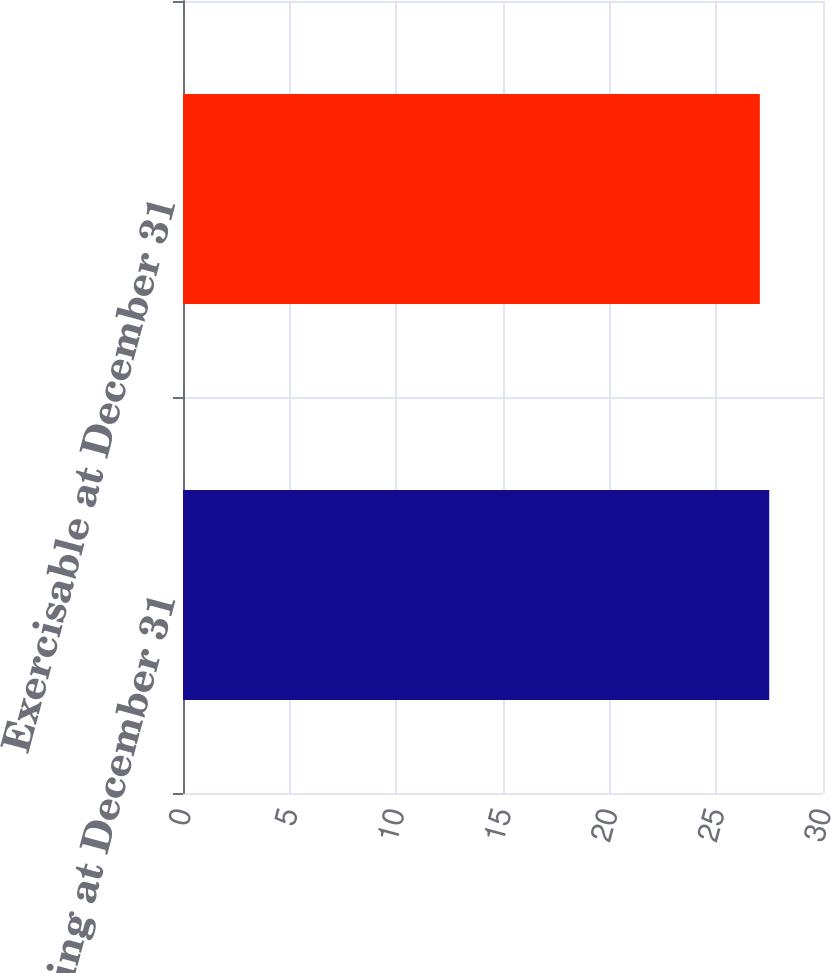Convert chart to OTSL. <chart><loc_0><loc_0><loc_500><loc_500><bar_chart><fcel>Outstanding at December 31<fcel>Exercisable at December 31<nl><fcel>27.48<fcel>27.04<nl></chart> 